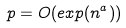<formula> <loc_0><loc_0><loc_500><loc_500>p = O ( e x p ( n ^ { a } ) )</formula> 